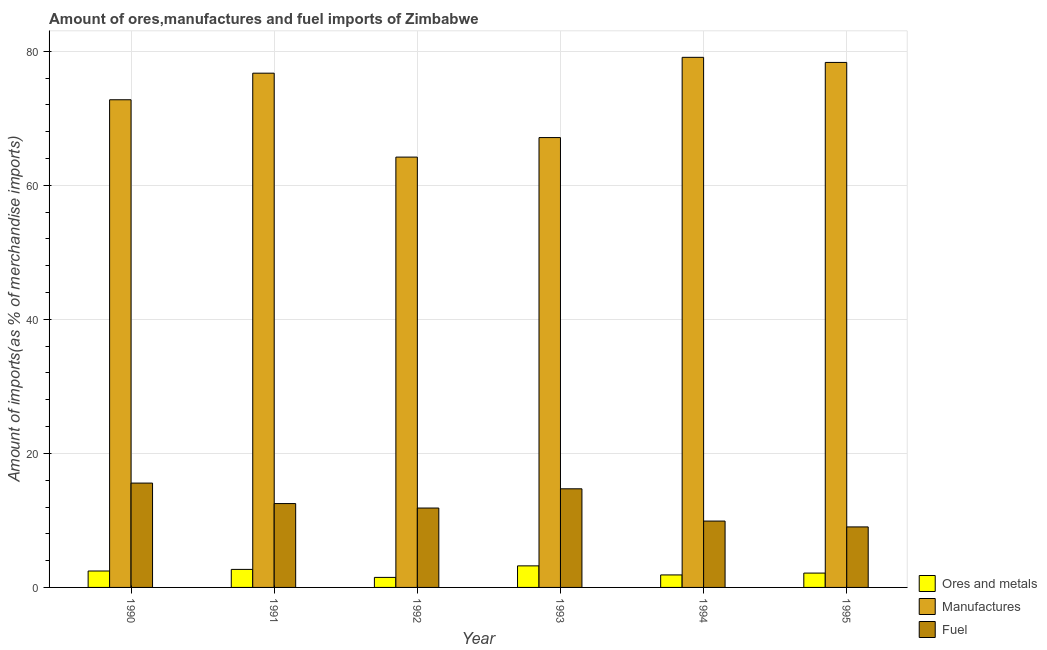How many different coloured bars are there?
Keep it short and to the point. 3. Are the number of bars on each tick of the X-axis equal?
Make the answer very short. Yes. How many bars are there on the 6th tick from the left?
Make the answer very short. 3. How many bars are there on the 3rd tick from the right?
Make the answer very short. 3. What is the label of the 5th group of bars from the left?
Make the answer very short. 1994. In how many cases, is the number of bars for a given year not equal to the number of legend labels?
Provide a short and direct response. 0. What is the percentage of fuel imports in 1992?
Offer a very short reply. 11.85. Across all years, what is the maximum percentage of manufactures imports?
Provide a succinct answer. 79.1. Across all years, what is the minimum percentage of manufactures imports?
Offer a very short reply. 64.21. In which year was the percentage of ores and metals imports maximum?
Provide a succinct answer. 1993. What is the total percentage of manufactures imports in the graph?
Offer a terse response. 438.3. What is the difference between the percentage of manufactures imports in 1993 and that in 1995?
Your response must be concise. -11.21. What is the difference between the percentage of manufactures imports in 1993 and the percentage of ores and metals imports in 1992?
Your response must be concise. 2.92. What is the average percentage of ores and metals imports per year?
Offer a very short reply. 2.31. What is the ratio of the percentage of ores and metals imports in 1993 to that in 1994?
Offer a terse response. 1.73. Is the difference between the percentage of manufactures imports in 1993 and 1995 greater than the difference between the percentage of ores and metals imports in 1993 and 1995?
Provide a short and direct response. No. What is the difference between the highest and the second highest percentage of fuel imports?
Your response must be concise. 0.85. What is the difference between the highest and the lowest percentage of manufactures imports?
Offer a very short reply. 14.89. Is the sum of the percentage of fuel imports in 1991 and 1994 greater than the maximum percentage of ores and metals imports across all years?
Give a very brief answer. Yes. What does the 3rd bar from the left in 1993 represents?
Offer a terse response. Fuel. What does the 2nd bar from the right in 1994 represents?
Keep it short and to the point. Manufactures. Are all the bars in the graph horizontal?
Ensure brevity in your answer.  No. How many years are there in the graph?
Keep it short and to the point. 6. What is the difference between two consecutive major ticks on the Y-axis?
Provide a short and direct response. 20. Does the graph contain any zero values?
Keep it short and to the point. No. Does the graph contain grids?
Your answer should be very brief. Yes. Where does the legend appear in the graph?
Your answer should be compact. Bottom right. How are the legend labels stacked?
Give a very brief answer. Vertical. What is the title of the graph?
Ensure brevity in your answer.  Amount of ores,manufactures and fuel imports of Zimbabwe. Does "Maunufacturing" appear as one of the legend labels in the graph?
Your answer should be compact. No. What is the label or title of the X-axis?
Provide a short and direct response. Year. What is the label or title of the Y-axis?
Make the answer very short. Amount of imports(as % of merchandise imports). What is the Amount of imports(as % of merchandise imports) in Ores and metals in 1990?
Your response must be concise. 2.45. What is the Amount of imports(as % of merchandise imports) of Manufactures in 1990?
Provide a succinct answer. 72.77. What is the Amount of imports(as % of merchandise imports) in Fuel in 1990?
Make the answer very short. 15.57. What is the Amount of imports(as % of merchandise imports) in Ores and metals in 1991?
Offer a terse response. 2.69. What is the Amount of imports(as % of merchandise imports) in Manufactures in 1991?
Your answer should be very brief. 76.74. What is the Amount of imports(as % of merchandise imports) of Fuel in 1991?
Your answer should be compact. 12.51. What is the Amount of imports(as % of merchandise imports) in Ores and metals in 1992?
Offer a terse response. 1.5. What is the Amount of imports(as % of merchandise imports) in Manufactures in 1992?
Your answer should be compact. 64.21. What is the Amount of imports(as % of merchandise imports) in Fuel in 1992?
Keep it short and to the point. 11.85. What is the Amount of imports(as % of merchandise imports) in Ores and metals in 1993?
Offer a terse response. 3.22. What is the Amount of imports(as % of merchandise imports) in Manufactures in 1993?
Ensure brevity in your answer.  67.13. What is the Amount of imports(as % of merchandise imports) in Fuel in 1993?
Ensure brevity in your answer.  14.72. What is the Amount of imports(as % of merchandise imports) in Ores and metals in 1994?
Provide a short and direct response. 1.86. What is the Amount of imports(as % of merchandise imports) in Manufactures in 1994?
Your response must be concise. 79.1. What is the Amount of imports(as % of merchandise imports) in Fuel in 1994?
Offer a very short reply. 9.9. What is the Amount of imports(as % of merchandise imports) of Ores and metals in 1995?
Provide a succinct answer. 2.14. What is the Amount of imports(as % of merchandise imports) of Manufactures in 1995?
Your answer should be very brief. 78.34. What is the Amount of imports(as % of merchandise imports) of Fuel in 1995?
Give a very brief answer. 9.03. Across all years, what is the maximum Amount of imports(as % of merchandise imports) in Ores and metals?
Provide a short and direct response. 3.22. Across all years, what is the maximum Amount of imports(as % of merchandise imports) of Manufactures?
Provide a succinct answer. 79.1. Across all years, what is the maximum Amount of imports(as % of merchandise imports) in Fuel?
Offer a very short reply. 15.57. Across all years, what is the minimum Amount of imports(as % of merchandise imports) of Ores and metals?
Make the answer very short. 1.5. Across all years, what is the minimum Amount of imports(as % of merchandise imports) in Manufactures?
Give a very brief answer. 64.21. Across all years, what is the minimum Amount of imports(as % of merchandise imports) of Fuel?
Offer a terse response. 9.03. What is the total Amount of imports(as % of merchandise imports) of Ores and metals in the graph?
Offer a terse response. 13.86. What is the total Amount of imports(as % of merchandise imports) of Manufactures in the graph?
Your answer should be very brief. 438.3. What is the total Amount of imports(as % of merchandise imports) of Fuel in the graph?
Ensure brevity in your answer.  73.58. What is the difference between the Amount of imports(as % of merchandise imports) in Ores and metals in 1990 and that in 1991?
Provide a succinct answer. -0.24. What is the difference between the Amount of imports(as % of merchandise imports) in Manufactures in 1990 and that in 1991?
Keep it short and to the point. -3.97. What is the difference between the Amount of imports(as % of merchandise imports) of Fuel in 1990 and that in 1991?
Your answer should be compact. 3.06. What is the difference between the Amount of imports(as % of merchandise imports) of Ores and metals in 1990 and that in 1992?
Make the answer very short. 0.95. What is the difference between the Amount of imports(as % of merchandise imports) of Manufactures in 1990 and that in 1992?
Provide a succinct answer. 8.56. What is the difference between the Amount of imports(as % of merchandise imports) of Fuel in 1990 and that in 1992?
Offer a very short reply. 3.72. What is the difference between the Amount of imports(as % of merchandise imports) of Ores and metals in 1990 and that in 1993?
Make the answer very short. -0.77. What is the difference between the Amount of imports(as % of merchandise imports) of Manufactures in 1990 and that in 1993?
Provide a succinct answer. 5.64. What is the difference between the Amount of imports(as % of merchandise imports) in Fuel in 1990 and that in 1993?
Provide a short and direct response. 0.85. What is the difference between the Amount of imports(as % of merchandise imports) in Ores and metals in 1990 and that in 1994?
Give a very brief answer. 0.59. What is the difference between the Amount of imports(as % of merchandise imports) in Manufactures in 1990 and that in 1994?
Offer a very short reply. -6.33. What is the difference between the Amount of imports(as % of merchandise imports) of Fuel in 1990 and that in 1994?
Provide a succinct answer. 5.67. What is the difference between the Amount of imports(as % of merchandise imports) in Ores and metals in 1990 and that in 1995?
Provide a short and direct response. 0.31. What is the difference between the Amount of imports(as % of merchandise imports) of Manufactures in 1990 and that in 1995?
Keep it short and to the point. -5.57. What is the difference between the Amount of imports(as % of merchandise imports) of Fuel in 1990 and that in 1995?
Make the answer very short. 6.54. What is the difference between the Amount of imports(as % of merchandise imports) in Ores and metals in 1991 and that in 1992?
Your response must be concise. 1.19. What is the difference between the Amount of imports(as % of merchandise imports) in Manufactures in 1991 and that in 1992?
Ensure brevity in your answer.  12.52. What is the difference between the Amount of imports(as % of merchandise imports) of Fuel in 1991 and that in 1992?
Your answer should be very brief. 0.67. What is the difference between the Amount of imports(as % of merchandise imports) of Ores and metals in 1991 and that in 1993?
Offer a very short reply. -0.53. What is the difference between the Amount of imports(as % of merchandise imports) of Manufactures in 1991 and that in 1993?
Your response must be concise. 9.61. What is the difference between the Amount of imports(as % of merchandise imports) of Fuel in 1991 and that in 1993?
Provide a short and direct response. -2.2. What is the difference between the Amount of imports(as % of merchandise imports) of Ores and metals in 1991 and that in 1994?
Ensure brevity in your answer.  0.83. What is the difference between the Amount of imports(as % of merchandise imports) of Manufactures in 1991 and that in 1994?
Provide a succinct answer. -2.37. What is the difference between the Amount of imports(as % of merchandise imports) in Fuel in 1991 and that in 1994?
Your answer should be very brief. 2.61. What is the difference between the Amount of imports(as % of merchandise imports) of Ores and metals in 1991 and that in 1995?
Ensure brevity in your answer.  0.55. What is the difference between the Amount of imports(as % of merchandise imports) in Manufactures in 1991 and that in 1995?
Offer a very short reply. -1.6. What is the difference between the Amount of imports(as % of merchandise imports) in Fuel in 1991 and that in 1995?
Make the answer very short. 3.48. What is the difference between the Amount of imports(as % of merchandise imports) in Ores and metals in 1992 and that in 1993?
Keep it short and to the point. -1.72. What is the difference between the Amount of imports(as % of merchandise imports) of Manufactures in 1992 and that in 1993?
Ensure brevity in your answer.  -2.92. What is the difference between the Amount of imports(as % of merchandise imports) of Fuel in 1992 and that in 1993?
Your response must be concise. -2.87. What is the difference between the Amount of imports(as % of merchandise imports) in Ores and metals in 1992 and that in 1994?
Make the answer very short. -0.37. What is the difference between the Amount of imports(as % of merchandise imports) of Manufactures in 1992 and that in 1994?
Give a very brief answer. -14.89. What is the difference between the Amount of imports(as % of merchandise imports) of Fuel in 1992 and that in 1994?
Give a very brief answer. 1.94. What is the difference between the Amount of imports(as % of merchandise imports) of Ores and metals in 1992 and that in 1995?
Offer a terse response. -0.64. What is the difference between the Amount of imports(as % of merchandise imports) in Manufactures in 1992 and that in 1995?
Ensure brevity in your answer.  -14.13. What is the difference between the Amount of imports(as % of merchandise imports) of Fuel in 1992 and that in 1995?
Keep it short and to the point. 2.82. What is the difference between the Amount of imports(as % of merchandise imports) in Ores and metals in 1993 and that in 1994?
Make the answer very short. 1.35. What is the difference between the Amount of imports(as % of merchandise imports) in Manufactures in 1993 and that in 1994?
Your response must be concise. -11.97. What is the difference between the Amount of imports(as % of merchandise imports) of Fuel in 1993 and that in 1994?
Make the answer very short. 4.81. What is the difference between the Amount of imports(as % of merchandise imports) of Ores and metals in 1993 and that in 1995?
Make the answer very short. 1.08. What is the difference between the Amount of imports(as % of merchandise imports) in Manufactures in 1993 and that in 1995?
Provide a succinct answer. -11.21. What is the difference between the Amount of imports(as % of merchandise imports) of Fuel in 1993 and that in 1995?
Ensure brevity in your answer.  5.69. What is the difference between the Amount of imports(as % of merchandise imports) in Ores and metals in 1994 and that in 1995?
Provide a succinct answer. -0.28. What is the difference between the Amount of imports(as % of merchandise imports) of Manufactures in 1994 and that in 1995?
Give a very brief answer. 0.76. What is the difference between the Amount of imports(as % of merchandise imports) of Fuel in 1994 and that in 1995?
Provide a succinct answer. 0.87. What is the difference between the Amount of imports(as % of merchandise imports) in Ores and metals in 1990 and the Amount of imports(as % of merchandise imports) in Manufactures in 1991?
Your answer should be very brief. -74.29. What is the difference between the Amount of imports(as % of merchandise imports) of Ores and metals in 1990 and the Amount of imports(as % of merchandise imports) of Fuel in 1991?
Ensure brevity in your answer.  -10.06. What is the difference between the Amount of imports(as % of merchandise imports) in Manufactures in 1990 and the Amount of imports(as % of merchandise imports) in Fuel in 1991?
Make the answer very short. 60.26. What is the difference between the Amount of imports(as % of merchandise imports) in Ores and metals in 1990 and the Amount of imports(as % of merchandise imports) in Manufactures in 1992?
Offer a terse response. -61.77. What is the difference between the Amount of imports(as % of merchandise imports) in Ores and metals in 1990 and the Amount of imports(as % of merchandise imports) in Fuel in 1992?
Offer a very short reply. -9.4. What is the difference between the Amount of imports(as % of merchandise imports) in Manufactures in 1990 and the Amount of imports(as % of merchandise imports) in Fuel in 1992?
Give a very brief answer. 60.93. What is the difference between the Amount of imports(as % of merchandise imports) in Ores and metals in 1990 and the Amount of imports(as % of merchandise imports) in Manufactures in 1993?
Give a very brief answer. -64.68. What is the difference between the Amount of imports(as % of merchandise imports) in Ores and metals in 1990 and the Amount of imports(as % of merchandise imports) in Fuel in 1993?
Your answer should be very brief. -12.27. What is the difference between the Amount of imports(as % of merchandise imports) of Manufactures in 1990 and the Amount of imports(as % of merchandise imports) of Fuel in 1993?
Your answer should be compact. 58.06. What is the difference between the Amount of imports(as % of merchandise imports) in Ores and metals in 1990 and the Amount of imports(as % of merchandise imports) in Manufactures in 1994?
Provide a short and direct response. -76.65. What is the difference between the Amount of imports(as % of merchandise imports) in Ores and metals in 1990 and the Amount of imports(as % of merchandise imports) in Fuel in 1994?
Provide a succinct answer. -7.45. What is the difference between the Amount of imports(as % of merchandise imports) in Manufactures in 1990 and the Amount of imports(as % of merchandise imports) in Fuel in 1994?
Your answer should be very brief. 62.87. What is the difference between the Amount of imports(as % of merchandise imports) in Ores and metals in 1990 and the Amount of imports(as % of merchandise imports) in Manufactures in 1995?
Give a very brief answer. -75.89. What is the difference between the Amount of imports(as % of merchandise imports) in Ores and metals in 1990 and the Amount of imports(as % of merchandise imports) in Fuel in 1995?
Offer a very short reply. -6.58. What is the difference between the Amount of imports(as % of merchandise imports) of Manufactures in 1990 and the Amount of imports(as % of merchandise imports) of Fuel in 1995?
Keep it short and to the point. 63.74. What is the difference between the Amount of imports(as % of merchandise imports) of Ores and metals in 1991 and the Amount of imports(as % of merchandise imports) of Manufactures in 1992?
Your answer should be compact. -61.53. What is the difference between the Amount of imports(as % of merchandise imports) of Ores and metals in 1991 and the Amount of imports(as % of merchandise imports) of Fuel in 1992?
Provide a short and direct response. -9.16. What is the difference between the Amount of imports(as % of merchandise imports) in Manufactures in 1991 and the Amount of imports(as % of merchandise imports) in Fuel in 1992?
Make the answer very short. 64.89. What is the difference between the Amount of imports(as % of merchandise imports) of Ores and metals in 1991 and the Amount of imports(as % of merchandise imports) of Manufactures in 1993?
Provide a succinct answer. -64.44. What is the difference between the Amount of imports(as % of merchandise imports) in Ores and metals in 1991 and the Amount of imports(as % of merchandise imports) in Fuel in 1993?
Offer a terse response. -12.03. What is the difference between the Amount of imports(as % of merchandise imports) in Manufactures in 1991 and the Amount of imports(as % of merchandise imports) in Fuel in 1993?
Your answer should be very brief. 62.02. What is the difference between the Amount of imports(as % of merchandise imports) of Ores and metals in 1991 and the Amount of imports(as % of merchandise imports) of Manufactures in 1994?
Offer a very short reply. -76.41. What is the difference between the Amount of imports(as % of merchandise imports) in Ores and metals in 1991 and the Amount of imports(as % of merchandise imports) in Fuel in 1994?
Ensure brevity in your answer.  -7.21. What is the difference between the Amount of imports(as % of merchandise imports) in Manufactures in 1991 and the Amount of imports(as % of merchandise imports) in Fuel in 1994?
Offer a terse response. 66.83. What is the difference between the Amount of imports(as % of merchandise imports) of Ores and metals in 1991 and the Amount of imports(as % of merchandise imports) of Manufactures in 1995?
Offer a very short reply. -75.65. What is the difference between the Amount of imports(as % of merchandise imports) of Ores and metals in 1991 and the Amount of imports(as % of merchandise imports) of Fuel in 1995?
Your answer should be compact. -6.34. What is the difference between the Amount of imports(as % of merchandise imports) of Manufactures in 1991 and the Amount of imports(as % of merchandise imports) of Fuel in 1995?
Ensure brevity in your answer.  67.71. What is the difference between the Amount of imports(as % of merchandise imports) of Ores and metals in 1992 and the Amount of imports(as % of merchandise imports) of Manufactures in 1993?
Provide a succinct answer. -65.63. What is the difference between the Amount of imports(as % of merchandise imports) in Ores and metals in 1992 and the Amount of imports(as % of merchandise imports) in Fuel in 1993?
Keep it short and to the point. -13.22. What is the difference between the Amount of imports(as % of merchandise imports) in Manufactures in 1992 and the Amount of imports(as % of merchandise imports) in Fuel in 1993?
Your response must be concise. 49.5. What is the difference between the Amount of imports(as % of merchandise imports) of Ores and metals in 1992 and the Amount of imports(as % of merchandise imports) of Manufactures in 1994?
Provide a short and direct response. -77.61. What is the difference between the Amount of imports(as % of merchandise imports) of Ores and metals in 1992 and the Amount of imports(as % of merchandise imports) of Fuel in 1994?
Your response must be concise. -8.41. What is the difference between the Amount of imports(as % of merchandise imports) in Manufactures in 1992 and the Amount of imports(as % of merchandise imports) in Fuel in 1994?
Ensure brevity in your answer.  54.31. What is the difference between the Amount of imports(as % of merchandise imports) of Ores and metals in 1992 and the Amount of imports(as % of merchandise imports) of Manufactures in 1995?
Keep it short and to the point. -76.85. What is the difference between the Amount of imports(as % of merchandise imports) in Ores and metals in 1992 and the Amount of imports(as % of merchandise imports) in Fuel in 1995?
Provide a succinct answer. -7.53. What is the difference between the Amount of imports(as % of merchandise imports) of Manufactures in 1992 and the Amount of imports(as % of merchandise imports) of Fuel in 1995?
Give a very brief answer. 55.19. What is the difference between the Amount of imports(as % of merchandise imports) in Ores and metals in 1993 and the Amount of imports(as % of merchandise imports) in Manufactures in 1994?
Provide a succinct answer. -75.89. What is the difference between the Amount of imports(as % of merchandise imports) in Ores and metals in 1993 and the Amount of imports(as % of merchandise imports) in Fuel in 1994?
Your answer should be compact. -6.69. What is the difference between the Amount of imports(as % of merchandise imports) in Manufactures in 1993 and the Amount of imports(as % of merchandise imports) in Fuel in 1994?
Make the answer very short. 57.23. What is the difference between the Amount of imports(as % of merchandise imports) of Ores and metals in 1993 and the Amount of imports(as % of merchandise imports) of Manufactures in 1995?
Keep it short and to the point. -75.12. What is the difference between the Amount of imports(as % of merchandise imports) of Ores and metals in 1993 and the Amount of imports(as % of merchandise imports) of Fuel in 1995?
Provide a succinct answer. -5.81. What is the difference between the Amount of imports(as % of merchandise imports) of Manufactures in 1993 and the Amount of imports(as % of merchandise imports) of Fuel in 1995?
Your response must be concise. 58.1. What is the difference between the Amount of imports(as % of merchandise imports) of Ores and metals in 1994 and the Amount of imports(as % of merchandise imports) of Manufactures in 1995?
Provide a succinct answer. -76.48. What is the difference between the Amount of imports(as % of merchandise imports) in Ores and metals in 1994 and the Amount of imports(as % of merchandise imports) in Fuel in 1995?
Ensure brevity in your answer.  -7.17. What is the difference between the Amount of imports(as % of merchandise imports) in Manufactures in 1994 and the Amount of imports(as % of merchandise imports) in Fuel in 1995?
Your answer should be very brief. 70.07. What is the average Amount of imports(as % of merchandise imports) of Ores and metals per year?
Your response must be concise. 2.31. What is the average Amount of imports(as % of merchandise imports) of Manufactures per year?
Your response must be concise. 73.05. What is the average Amount of imports(as % of merchandise imports) in Fuel per year?
Keep it short and to the point. 12.26. In the year 1990, what is the difference between the Amount of imports(as % of merchandise imports) of Ores and metals and Amount of imports(as % of merchandise imports) of Manufactures?
Offer a very short reply. -70.32. In the year 1990, what is the difference between the Amount of imports(as % of merchandise imports) of Ores and metals and Amount of imports(as % of merchandise imports) of Fuel?
Ensure brevity in your answer.  -13.12. In the year 1990, what is the difference between the Amount of imports(as % of merchandise imports) of Manufactures and Amount of imports(as % of merchandise imports) of Fuel?
Give a very brief answer. 57.2. In the year 1991, what is the difference between the Amount of imports(as % of merchandise imports) in Ores and metals and Amount of imports(as % of merchandise imports) in Manufactures?
Your answer should be compact. -74.05. In the year 1991, what is the difference between the Amount of imports(as % of merchandise imports) in Ores and metals and Amount of imports(as % of merchandise imports) in Fuel?
Ensure brevity in your answer.  -9.82. In the year 1991, what is the difference between the Amount of imports(as % of merchandise imports) in Manufactures and Amount of imports(as % of merchandise imports) in Fuel?
Your answer should be very brief. 64.22. In the year 1992, what is the difference between the Amount of imports(as % of merchandise imports) in Ores and metals and Amount of imports(as % of merchandise imports) in Manufactures?
Provide a succinct answer. -62.72. In the year 1992, what is the difference between the Amount of imports(as % of merchandise imports) in Ores and metals and Amount of imports(as % of merchandise imports) in Fuel?
Give a very brief answer. -10.35. In the year 1992, what is the difference between the Amount of imports(as % of merchandise imports) in Manufactures and Amount of imports(as % of merchandise imports) in Fuel?
Make the answer very short. 52.37. In the year 1993, what is the difference between the Amount of imports(as % of merchandise imports) of Ores and metals and Amount of imports(as % of merchandise imports) of Manufactures?
Keep it short and to the point. -63.91. In the year 1993, what is the difference between the Amount of imports(as % of merchandise imports) of Ores and metals and Amount of imports(as % of merchandise imports) of Fuel?
Ensure brevity in your answer.  -11.5. In the year 1993, what is the difference between the Amount of imports(as % of merchandise imports) in Manufactures and Amount of imports(as % of merchandise imports) in Fuel?
Keep it short and to the point. 52.41. In the year 1994, what is the difference between the Amount of imports(as % of merchandise imports) in Ores and metals and Amount of imports(as % of merchandise imports) in Manufactures?
Provide a short and direct response. -77.24. In the year 1994, what is the difference between the Amount of imports(as % of merchandise imports) in Ores and metals and Amount of imports(as % of merchandise imports) in Fuel?
Keep it short and to the point. -8.04. In the year 1994, what is the difference between the Amount of imports(as % of merchandise imports) of Manufactures and Amount of imports(as % of merchandise imports) of Fuel?
Your response must be concise. 69.2. In the year 1995, what is the difference between the Amount of imports(as % of merchandise imports) in Ores and metals and Amount of imports(as % of merchandise imports) in Manufactures?
Offer a terse response. -76.2. In the year 1995, what is the difference between the Amount of imports(as % of merchandise imports) in Ores and metals and Amount of imports(as % of merchandise imports) in Fuel?
Provide a succinct answer. -6.89. In the year 1995, what is the difference between the Amount of imports(as % of merchandise imports) in Manufactures and Amount of imports(as % of merchandise imports) in Fuel?
Offer a terse response. 69.31. What is the ratio of the Amount of imports(as % of merchandise imports) in Ores and metals in 1990 to that in 1991?
Offer a very short reply. 0.91. What is the ratio of the Amount of imports(as % of merchandise imports) in Manufactures in 1990 to that in 1991?
Keep it short and to the point. 0.95. What is the ratio of the Amount of imports(as % of merchandise imports) in Fuel in 1990 to that in 1991?
Your answer should be compact. 1.24. What is the ratio of the Amount of imports(as % of merchandise imports) in Ores and metals in 1990 to that in 1992?
Provide a succinct answer. 1.64. What is the ratio of the Amount of imports(as % of merchandise imports) of Manufactures in 1990 to that in 1992?
Give a very brief answer. 1.13. What is the ratio of the Amount of imports(as % of merchandise imports) of Fuel in 1990 to that in 1992?
Make the answer very short. 1.31. What is the ratio of the Amount of imports(as % of merchandise imports) in Ores and metals in 1990 to that in 1993?
Your answer should be very brief. 0.76. What is the ratio of the Amount of imports(as % of merchandise imports) in Manufactures in 1990 to that in 1993?
Keep it short and to the point. 1.08. What is the ratio of the Amount of imports(as % of merchandise imports) in Fuel in 1990 to that in 1993?
Your answer should be compact. 1.06. What is the ratio of the Amount of imports(as % of merchandise imports) of Ores and metals in 1990 to that in 1994?
Ensure brevity in your answer.  1.31. What is the ratio of the Amount of imports(as % of merchandise imports) in Fuel in 1990 to that in 1994?
Offer a very short reply. 1.57. What is the ratio of the Amount of imports(as % of merchandise imports) of Ores and metals in 1990 to that in 1995?
Keep it short and to the point. 1.14. What is the ratio of the Amount of imports(as % of merchandise imports) of Manufactures in 1990 to that in 1995?
Make the answer very short. 0.93. What is the ratio of the Amount of imports(as % of merchandise imports) in Fuel in 1990 to that in 1995?
Provide a short and direct response. 1.72. What is the ratio of the Amount of imports(as % of merchandise imports) in Ores and metals in 1991 to that in 1992?
Provide a succinct answer. 1.8. What is the ratio of the Amount of imports(as % of merchandise imports) in Manufactures in 1991 to that in 1992?
Your answer should be very brief. 1.2. What is the ratio of the Amount of imports(as % of merchandise imports) of Fuel in 1991 to that in 1992?
Provide a short and direct response. 1.06. What is the ratio of the Amount of imports(as % of merchandise imports) of Ores and metals in 1991 to that in 1993?
Offer a terse response. 0.84. What is the ratio of the Amount of imports(as % of merchandise imports) of Manufactures in 1991 to that in 1993?
Your response must be concise. 1.14. What is the ratio of the Amount of imports(as % of merchandise imports) in Fuel in 1991 to that in 1993?
Give a very brief answer. 0.85. What is the ratio of the Amount of imports(as % of merchandise imports) in Ores and metals in 1991 to that in 1994?
Make the answer very short. 1.44. What is the ratio of the Amount of imports(as % of merchandise imports) of Manufactures in 1991 to that in 1994?
Make the answer very short. 0.97. What is the ratio of the Amount of imports(as % of merchandise imports) in Fuel in 1991 to that in 1994?
Ensure brevity in your answer.  1.26. What is the ratio of the Amount of imports(as % of merchandise imports) in Ores and metals in 1991 to that in 1995?
Keep it short and to the point. 1.26. What is the ratio of the Amount of imports(as % of merchandise imports) of Manufactures in 1991 to that in 1995?
Your answer should be very brief. 0.98. What is the ratio of the Amount of imports(as % of merchandise imports) of Fuel in 1991 to that in 1995?
Provide a short and direct response. 1.39. What is the ratio of the Amount of imports(as % of merchandise imports) of Ores and metals in 1992 to that in 1993?
Your answer should be compact. 0.47. What is the ratio of the Amount of imports(as % of merchandise imports) of Manufactures in 1992 to that in 1993?
Make the answer very short. 0.96. What is the ratio of the Amount of imports(as % of merchandise imports) of Fuel in 1992 to that in 1993?
Ensure brevity in your answer.  0.81. What is the ratio of the Amount of imports(as % of merchandise imports) of Ores and metals in 1992 to that in 1994?
Keep it short and to the point. 0.8. What is the ratio of the Amount of imports(as % of merchandise imports) in Manufactures in 1992 to that in 1994?
Offer a terse response. 0.81. What is the ratio of the Amount of imports(as % of merchandise imports) of Fuel in 1992 to that in 1994?
Give a very brief answer. 1.2. What is the ratio of the Amount of imports(as % of merchandise imports) in Ores and metals in 1992 to that in 1995?
Provide a short and direct response. 0.7. What is the ratio of the Amount of imports(as % of merchandise imports) in Manufactures in 1992 to that in 1995?
Provide a short and direct response. 0.82. What is the ratio of the Amount of imports(as % of merchandise imports) in Fuel in 1992 to that in 1995?
Offer a terse response. 1.31. What is the ratio of the Amount of imports(as % of merchandise imports) of Ores and metals in 1993 to that in 1994?
Your answer should be compact. 1.73. What is the ratio of the Amount of imports(as % of merchandise imports) in Manufactures in 1993 to that in 1994?
Provide a succinct answer. 0.85. What is the ratio of the Amount of imports(as % of merchandise imports) in Fuel in 1993 to that in 1994?
Your answer should be compact. 1.49. What is the ratio of the Amount of imports(as % of merchandise imports) in Ores and metals in 1993 to that in 1995?
Provide a short and direct response. 1.5. What is the ratio of the Amount of imports(as % of merchandise imports) of Manufactures in 1993 to that in 1995?
Your answer should be very brief. 0.86. What is the ratio of the Amount of imports(as % of merchandise imports) of Fuel in 1993 to that in 1995?
Your response must be concise. 1.63. What is the ratio of the Amount of imports(as % of merchandise imports) of Ores and metals in 1994 to that in 1995?
Your response must be concise. 0.87. What is the ratio of the Amount of imports(as % of merchandise imports) of Manufactures in 1994 to that in 1995?
Your answer should be compact. 1.01. What is the ratio of the Amount of imports(as % of merchandise imports) in Fuel in 1994 to that in 1995?
Ensure brevity in your answer.  1.1. What is the difference between the highest and the second highest Amount of imports(as % of merchandise imports) of Ores and metals?
Your answer should be compact. 0.53. What is the difference between the highest and the second highest Amount of imports(as % of merchandise imports) of Manufactures?
Your answer should be compact. 0.76. What is the difference between the highest and the second highest Amount of imports(as % of merchandise imports) in Fuel?
Offer a terse response. 0.85. What is the difference between the highest and the lowest Amount of imports(as % of merchandise imports) of Ores and metals?
Keep it short and to the point. 1.72. What is the difference between the highest and the lowest Amount of imports(as % of merchandise imports) of Manufactures?
Offer a very short reply. 14.89. What is the difference between the highest and the lowest Amount of imports(as % of merchandise imports) in Fuel?
Your response must be concise. 6.54. 